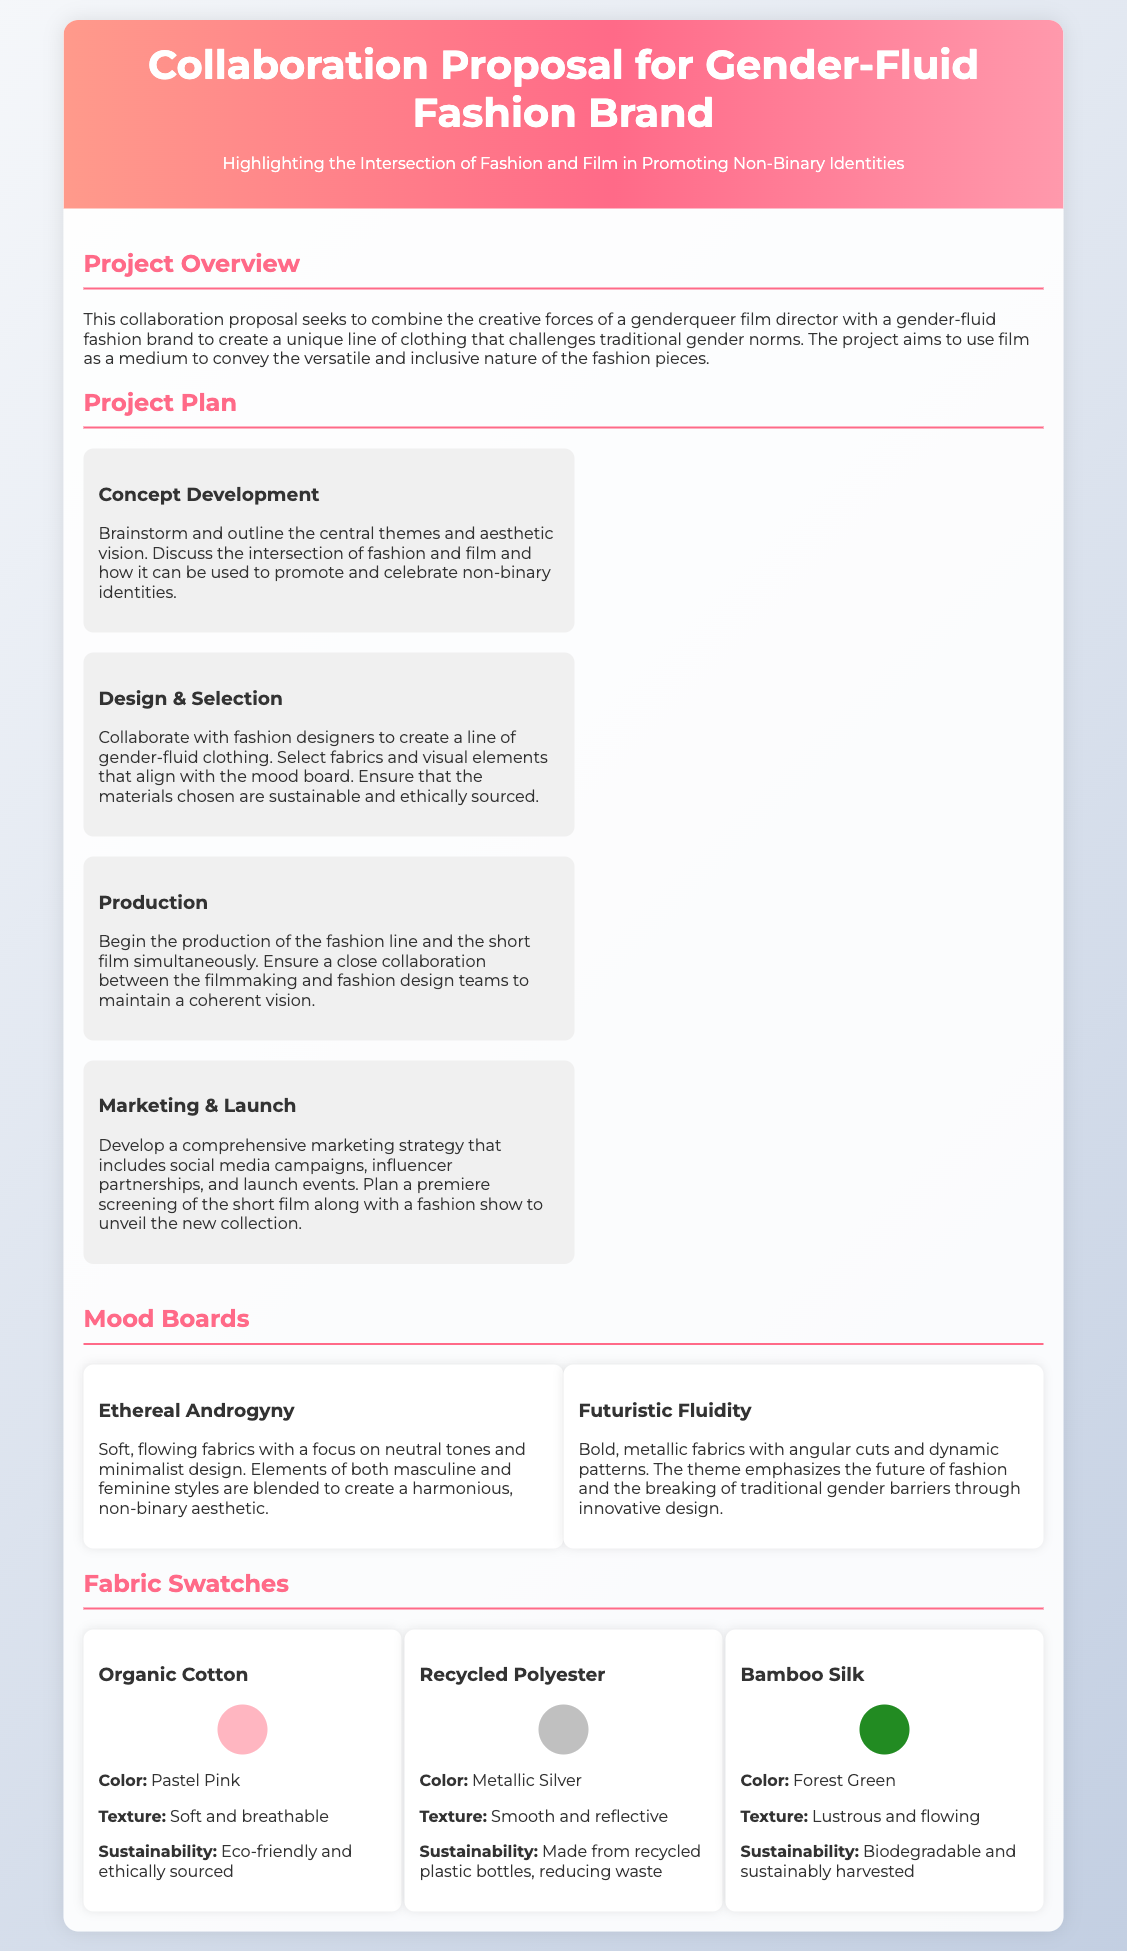What is the title of the proposal? The title of the proposal is provided in the header section of the document.
Answer: Collaboration Proposal for Gender-Fluid Fashion Brand What is the focus of the Project Overview? The Project Overview discusses the collaboration's aim to combine the creative forces to challenge traditional gender norms.
Answer: Challenging traditional gender norms How many stages are outlined in the Project Plan? The number of stages in the Project Plan can be counted from the section detailing them.
Answer: Four What is the color of the Organic Cotton fabric swatch? The color of the Organic Cotton fabric swatch is specified under its description.
Answer: Pastel Pink Which fabric is made from recycled plastic bottles? The document lists the materials along with descriptions, including sustainability aspects.
Answer: Recycled Polyester What theme is represented by the "Futuristic Fluidity" mood board? The theme of the mood board is stated in the description accompanying its title.
Answer: Breaking traditional gender barriers Which fabric is biodegradable and sustainably harvested? The sustainability information provided for each fabric will help identify this.
Answer: Bamboo Silk What is the purpose of the marketing strategy outlined in the Project Plan? The purpose can be inferred from the marketing stage details provided in the Project Plan.
Answer: Comprehensive marketing strategy What type of style is emphasized in the "Ethereal Androgyny" mood board? The style emphasis is outlined in the description of the mood board.
Answer: Androgyny 